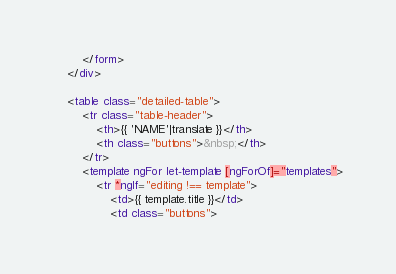<code> <loc_0><loc_0><loc_500><loc_500><_HTML_>        </form>
    </div>

    <table class="detailed-table">
        <tr class="table-header">
            <th>{{ 'NAME'|translate }}</th>
            <th class="buttons">&nbsp;</th>
        </tr>
        <template ngFor let-template [ngForOf]="templates">
            <tr *ngIf="editing !== template">
                <td>{{ template.title }}</td>
                <td class="buttons"></code> 